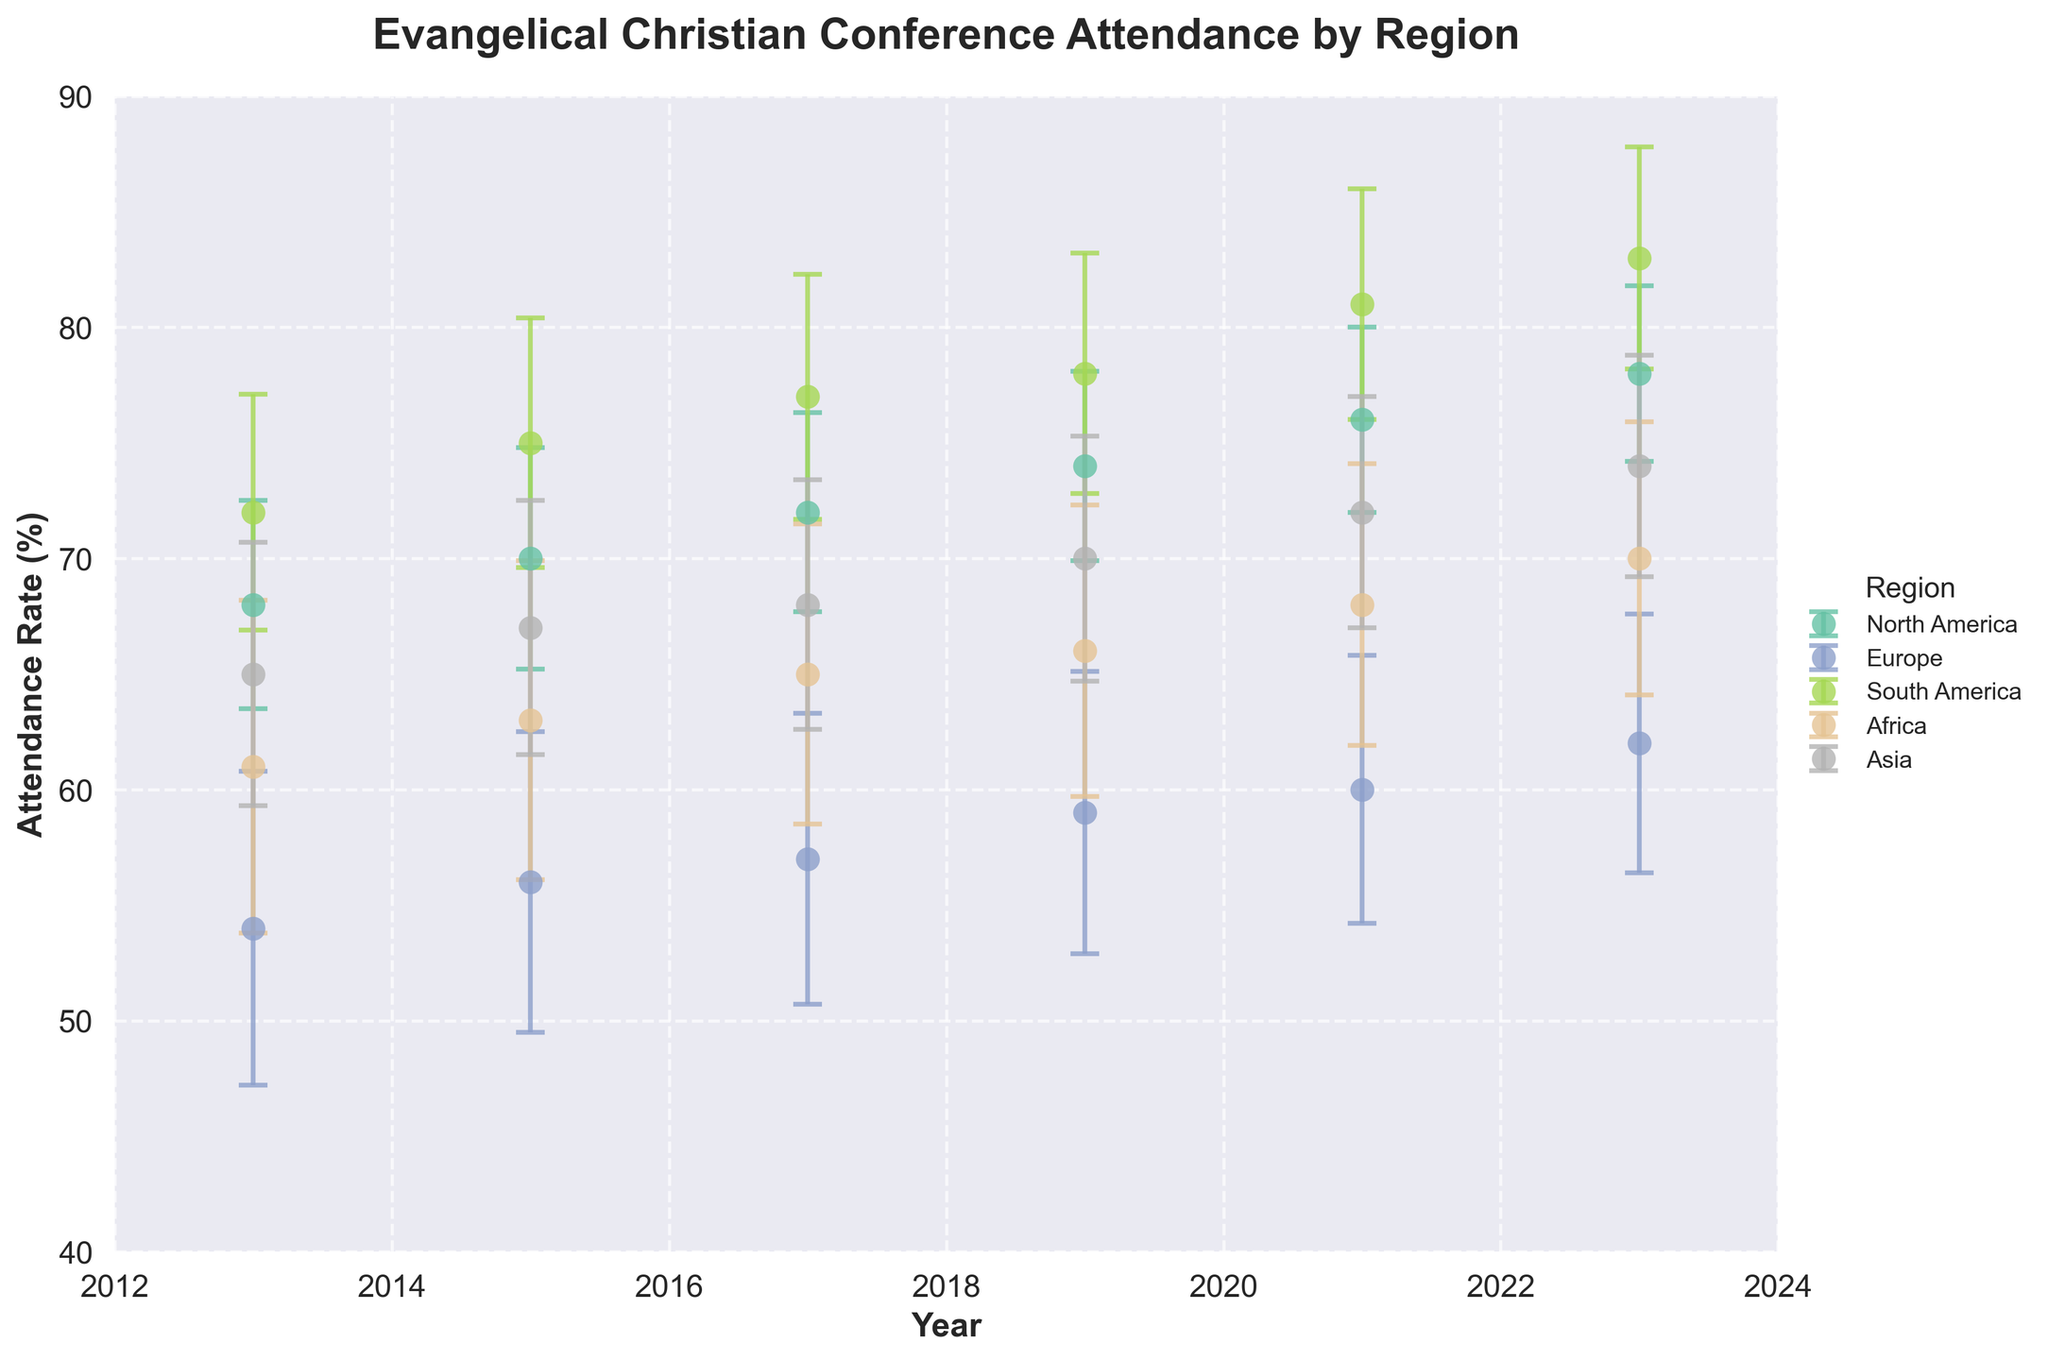What is the title of the figure? The title is usually found at the top of the figure. It provides a summary of what the figure is about.
Answer: Evangelical Christian Conference Attendance by Region What is the attendance rate for North America in 2023? Look for the data point for North America in the year 2023 on the X-axis and then check the corresponding Y-axis value.
Answer: 78% Which region had the lowest attendance rate in 2019? Identify the data points for all regions in 2019, then compare their Y-axis values to find the lowest.
Answer: Europe How does the attendance rate for South America change from 2013 to 2023? Look at the Y-axis values for South America in 2013 and 2023 and calculate the difference.
Answer: Increased by 11% (from 72% to 83%) Which region has the most consistent attendance rate over the years (considering the size of error bars)? Observe the error bars for each region and identify which region has the smallest and most uniform error bars indicating less variability.
Answer: North America What is the average attendance rate for Asia from 2013 to 2023? Sum up the attendance rates for Asia from 2013 to 2023 and then divide by the number of years (5).
Answer: (65 + 67 + 68 + 70 + 72 + 74) / 6 = 69.33% In which year did Africa have the highest attendance rate? Compare the Y-axis values for Africa across all years and identify the highest one.
Answer: 2023 Between which two consecutive years did Europe see the largest increase in attendance rate? Calculate the difference in attendance rates for Europe between each pair of consecutive years and identify the largest increase.
Answer: Between 2021 and 2023 (2% increase) Do any regions show a decreasing trend over the decade? Examine the trend lines for all regions and see if any have a negative slope.
Answer: No regions show a decreasing trend What is the range of the attendance rate for South America in 2023 considering the error bars? Add and subtract the standard deviation from the attendance rate for South America in 2023 to find the range.
Answer: 83% ± 4.8% = [78.2%, 87.8%] 